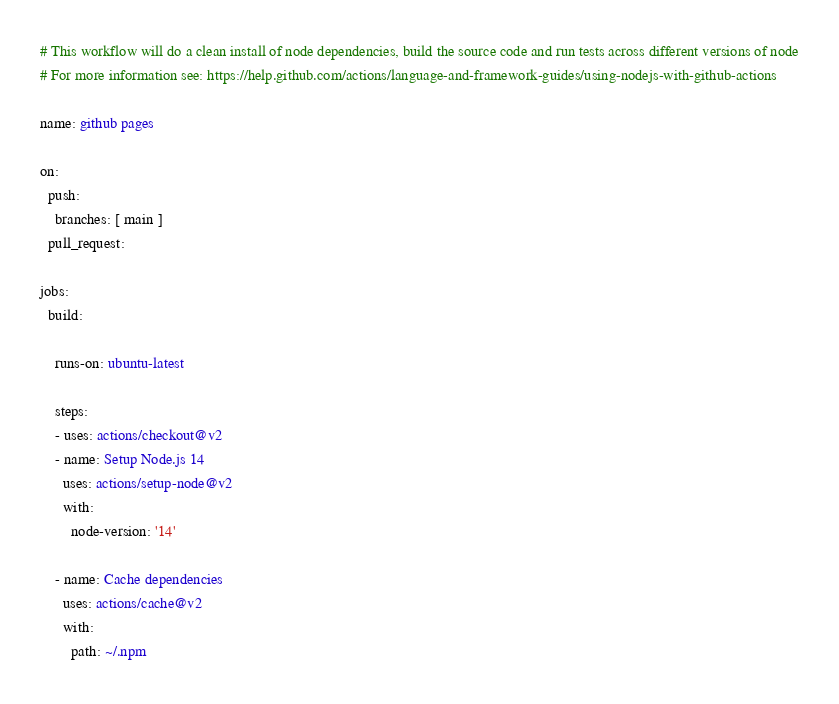Convert code to text. <code><loc_0><loc_0><loc_500><loc_500><_YAML_># This workflow will do a clean install of node dependencies, build the source code and run tests across different versions of node
# For more information see: https://help.github.com/actions/language-and-framework-guides/using-nodejs-with-github-actions

name: github pages

on:
  push:
    branches: [ main ]
  pull_request:

jobs:
  build:

    runs-on: ubuntu-latest

    steps:
    - uses: actions/checkout@v2
    - name: Setup Node.js 14
      uses: actions/setup-node@v2
      with:
        node-version: '14'
        
    - name: Cache dependencies
      uses: actions/cache@v2
      with:
        path: ~/.npm</code> 